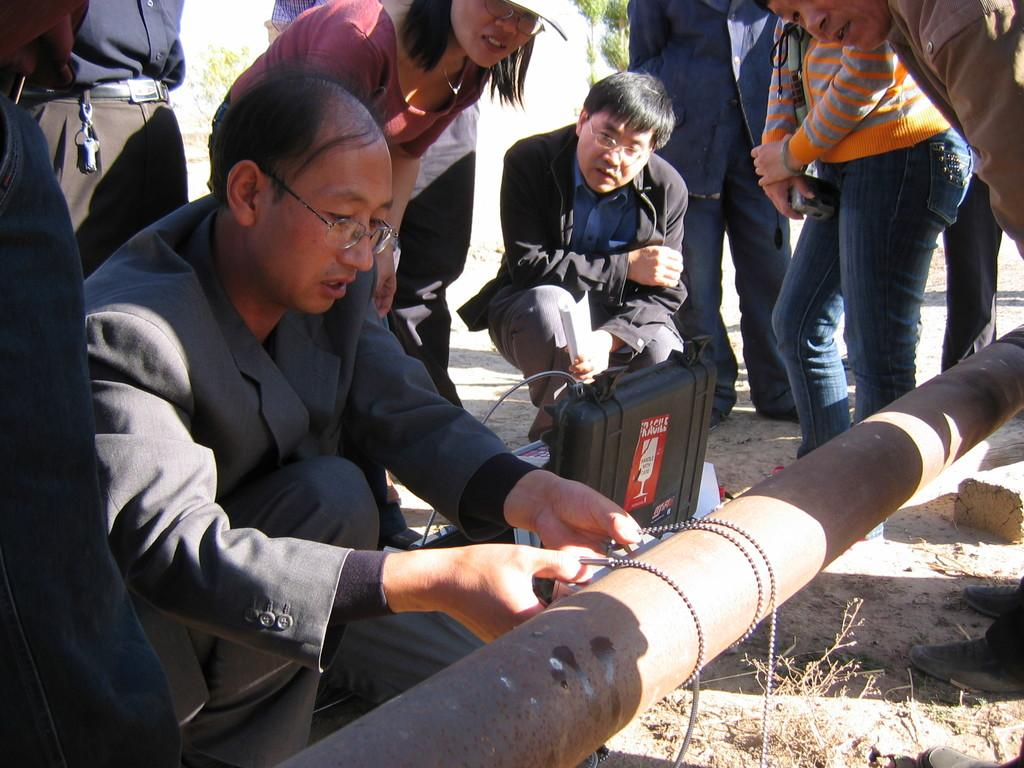How many people are present in the image? There are many people in the image. What can be seen in the image besides the people? There is a pole, objects placed on the ground, plants, and trees in the image. What type of window can be seen in the image? There is no window present in the image. What is the man doing in the image? There is no man present in the image. 